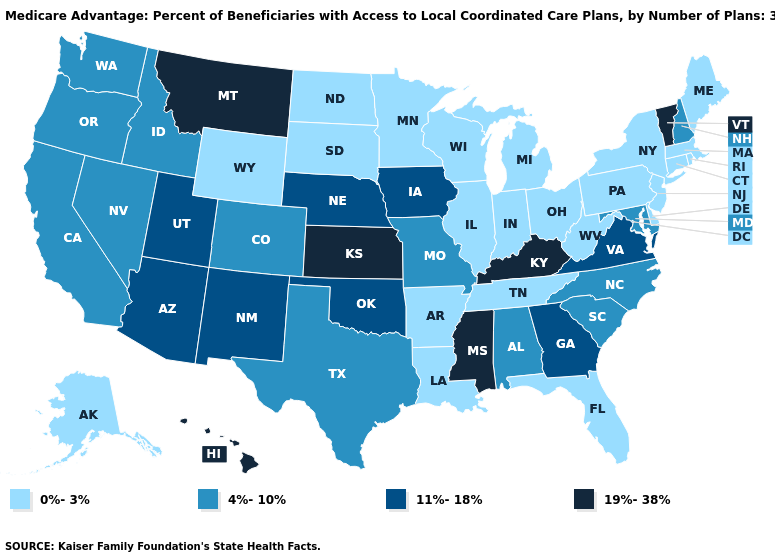Does the first symbol in the legend represent the smallest category?
Give a very brief answer. Yes. What is the highest value in the Northeast ?
Concise answer only. 19%-38%. Which states have the lowest value in the Northeast?
Keep it brief. Connecticut, Massachusetts, Maine, New Jersey, New York, Pennsylvania, Rhode Island. Name the states that have a value in the range 4%-10%?
Write a very short answer. California, Colorado, Idaho, Maryland, Missouri, North Carolina, New Hampshire, Nevada, Oregon, South Carolina, Texas, Washington, Alabama. What is the highest value in the Northeast ?
Give a very brief answer. 19%-38%. Does Nebraska have a lower value than Vermont?
Be succinct. Yes. Does Kansas have the highest value in the USA?
Be succinct. Yes. What is the highest value in states that border Montana?
Answer briefly. 4%-10%. What is the value of Kansas?
Keep it brief. 19%-38%. Is the legend a continuous bar?
Give a very brief answer. No. What is the highest value in the USA?
Short answer required. 19%-38%. Name the states that have a value in the range 11%-18%?
Keep it brief. Georgia, Iowa, Nebraska, New Mexico, Oklahoma, Utah, Virginia, Arizona. Which states hav the highest value in the South?
Keep it brief. Kentucky, Mississippi. Among the states that border South Dakota , which have the highest value?
Answer briefly. Montana. Name the states that have a value in the range 11%-18%?
Answer briefly. Georgia, Iowa, Nebraska, New Mexico, Oklahoma, Utah, Virginia, Arizona. 